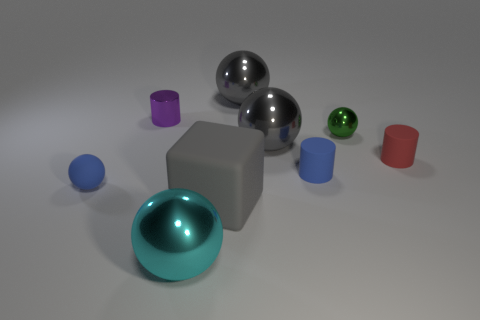Subtract all small rubber cylinders. How many cylinders are left? 1 Add 1 purple things. How many objects exist? 10 Subtract all blue balls. How many balls are left? 4 Subtract all cubes. How many objects are left? 8 Subtract all red balls. How many red blocks are left? 0 Subtract 0 purple cubes. How many objects are left? 9 Subtract 1 blocks. How many blocks are left? 0 Subtract all red spheres. Subtract all blue cylinders. How many spheres are left? 5 Subtract all big purple cubes. Subtract all big shiny spheres. How many objects are left? 6 Add 4 shiny things. How many shiny things are left? 9 